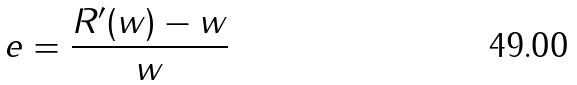Convert formula to latex. <formula><loc_0><loc_0><loc_500><loc_500>e = \frac { R ^ { \prime } ( w ) - w } { w }</formula> 